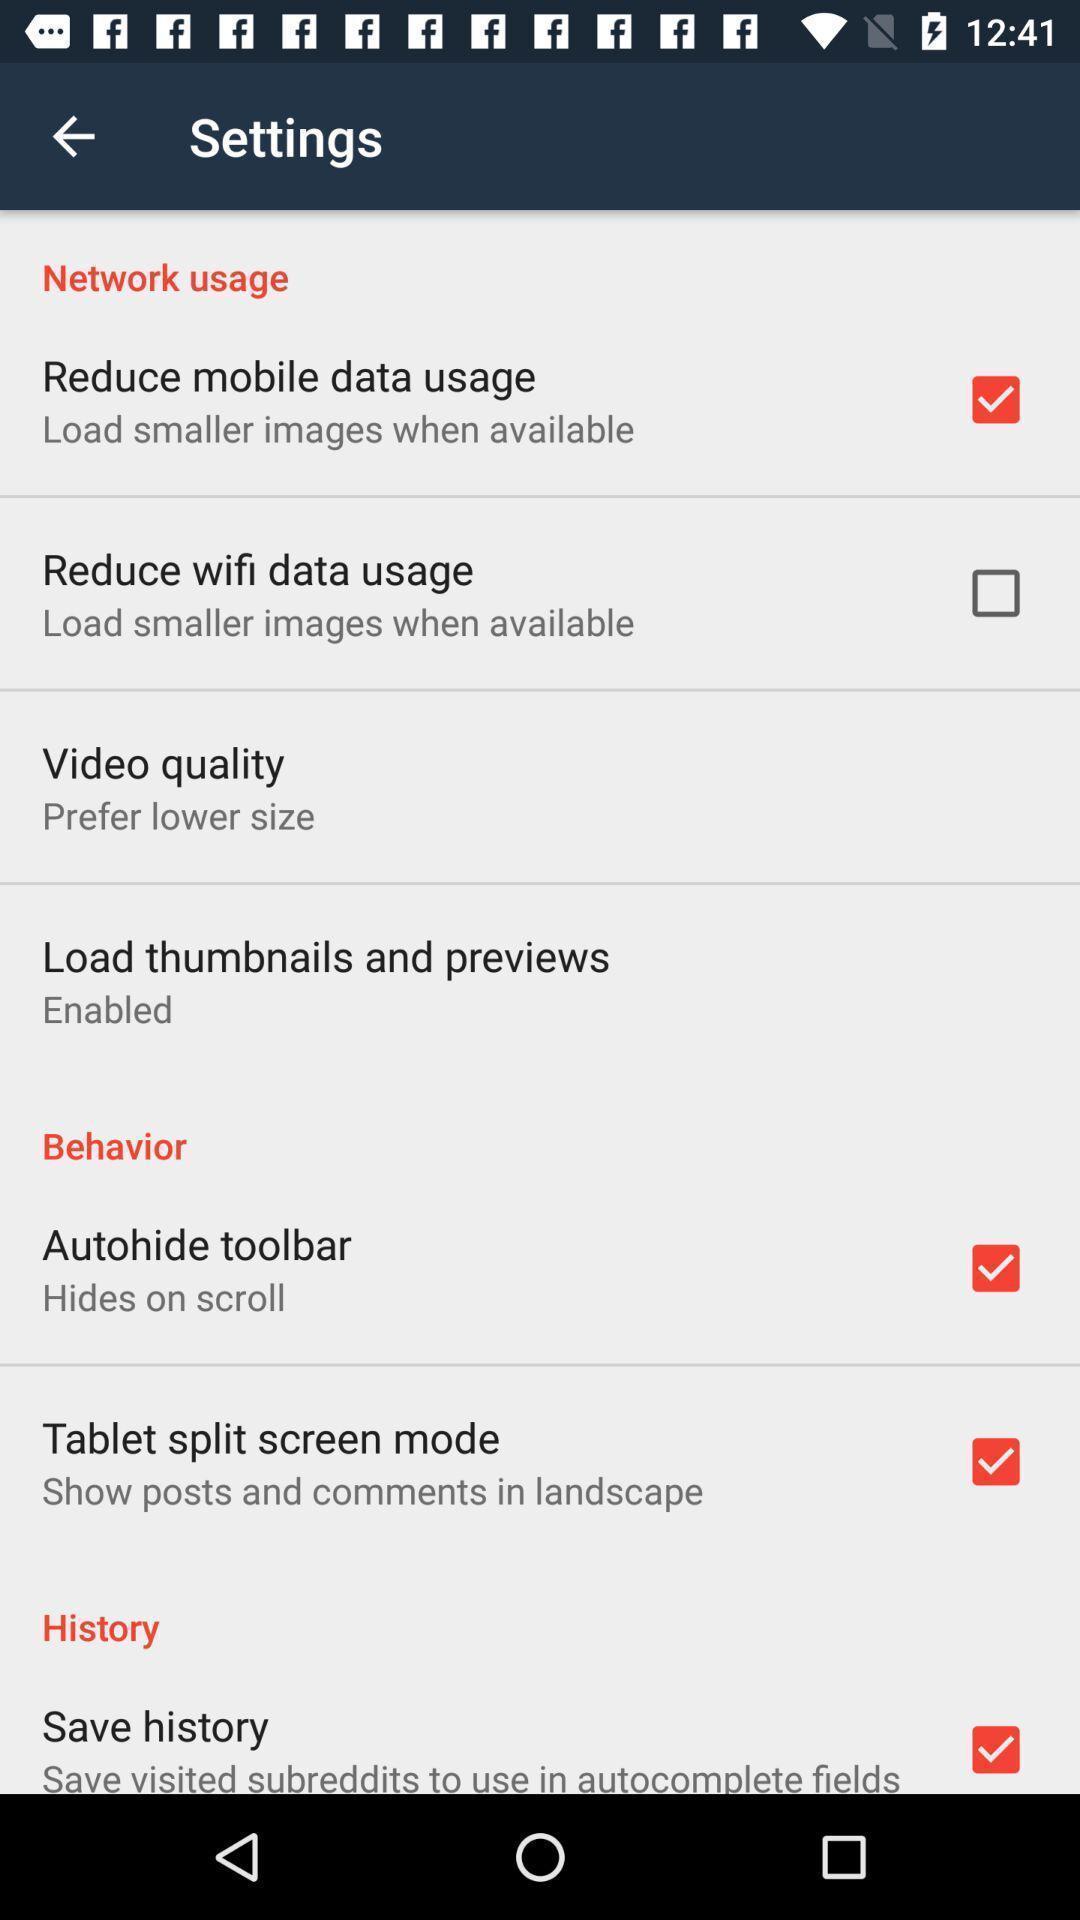Describe this image in words. Page displaying the various options of settings. 